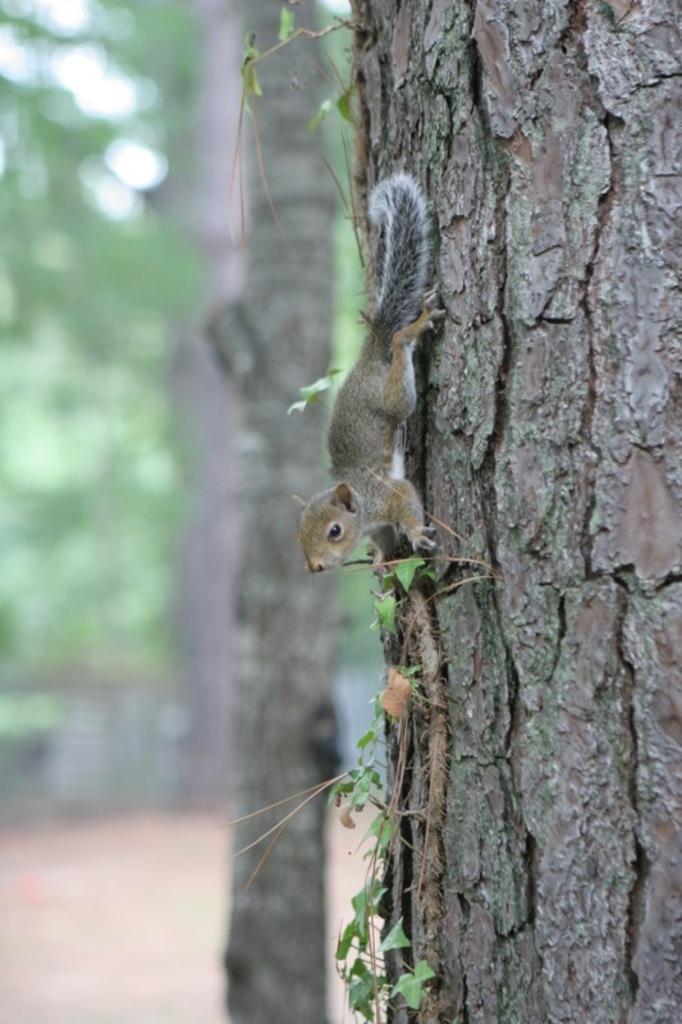Please provide a concise description of this image. In this image we can see a squirrel on the bark of a tree and some leaves. In the background, we can see some trees. 